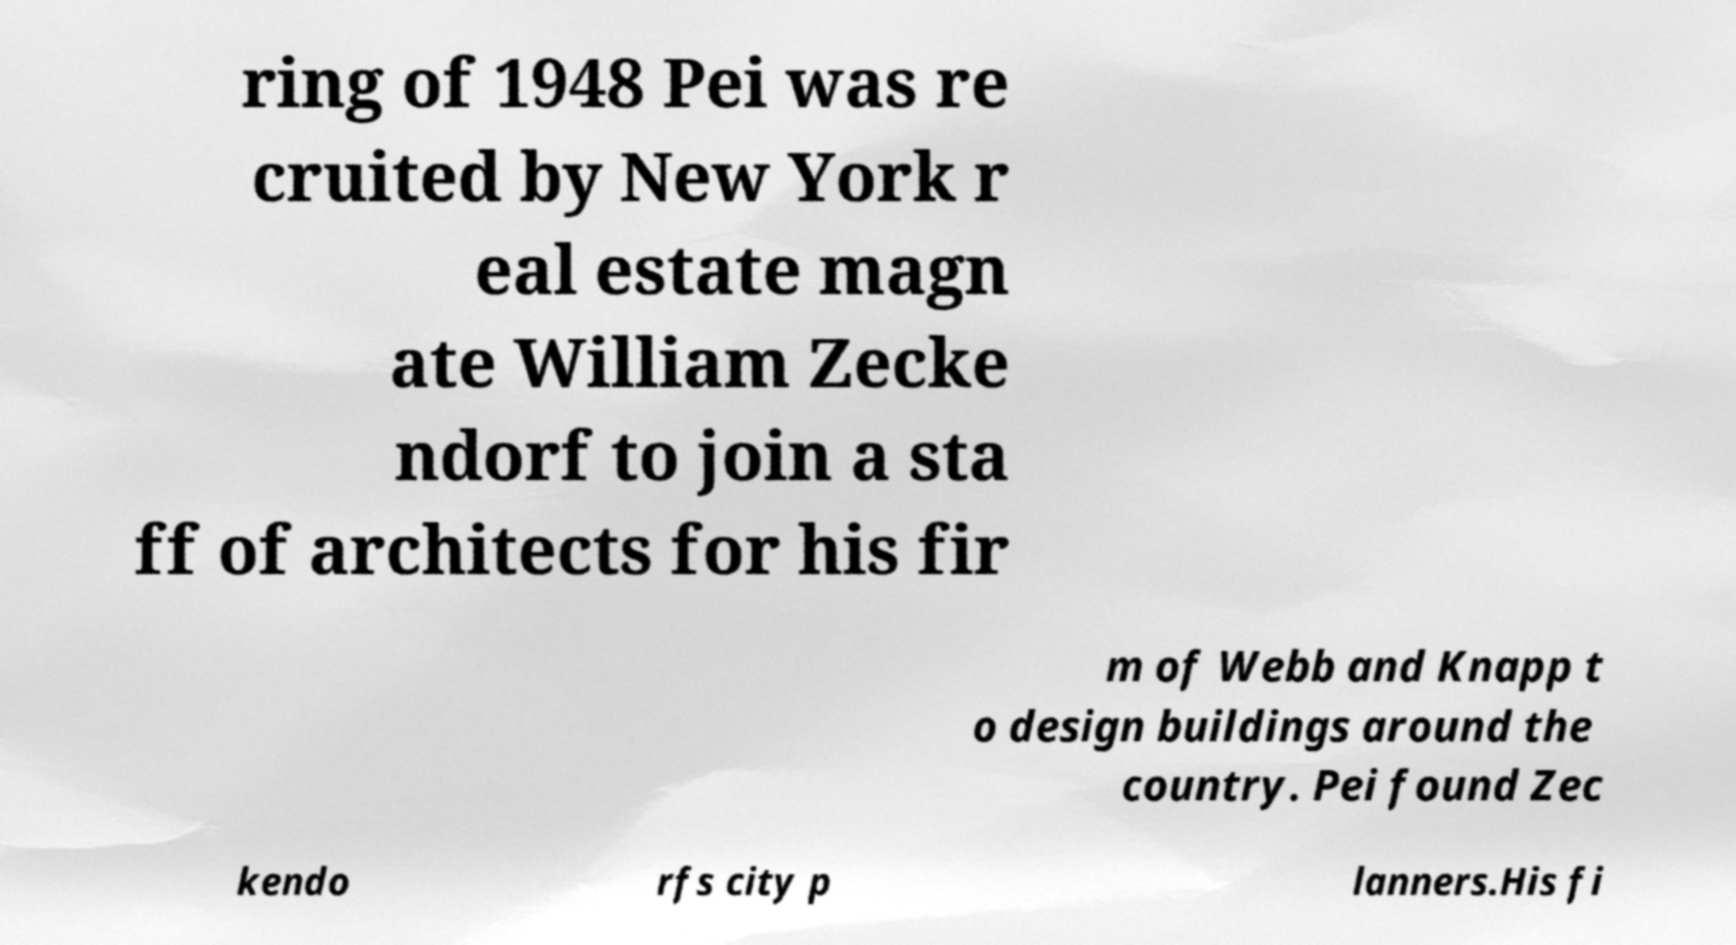Could you assist in decoding the text presented in this image and type it out clearly? ring of 1948 Pei was re cruited by New York r eal estate magn ate William Zecke ndorf to join a sta ff of architects for his fir m of Webb and Knapp t o design buildings around the country. Pei found Zec kendo rfs city p lanners.His fi 